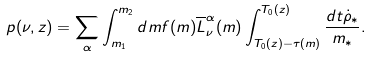Convert formula to latex. <formula><loc_0><loc_0><loc_500><loc_500>p ( \nu , z ) = \sum _ { \alpha } \int _ { m _ { 1 } } ^ { m _ { 2 } } d m f ( m ) \overline { L } _ { \nu } ^ { \alpha } ( m ) \int _ { T _ { 0 } ( z ) - \tau ( m ) } ^ { T _ { 0 } ( z ) } \frac { d t \dot { \rho } _ { * } } { m _ { * } } .</formula> 